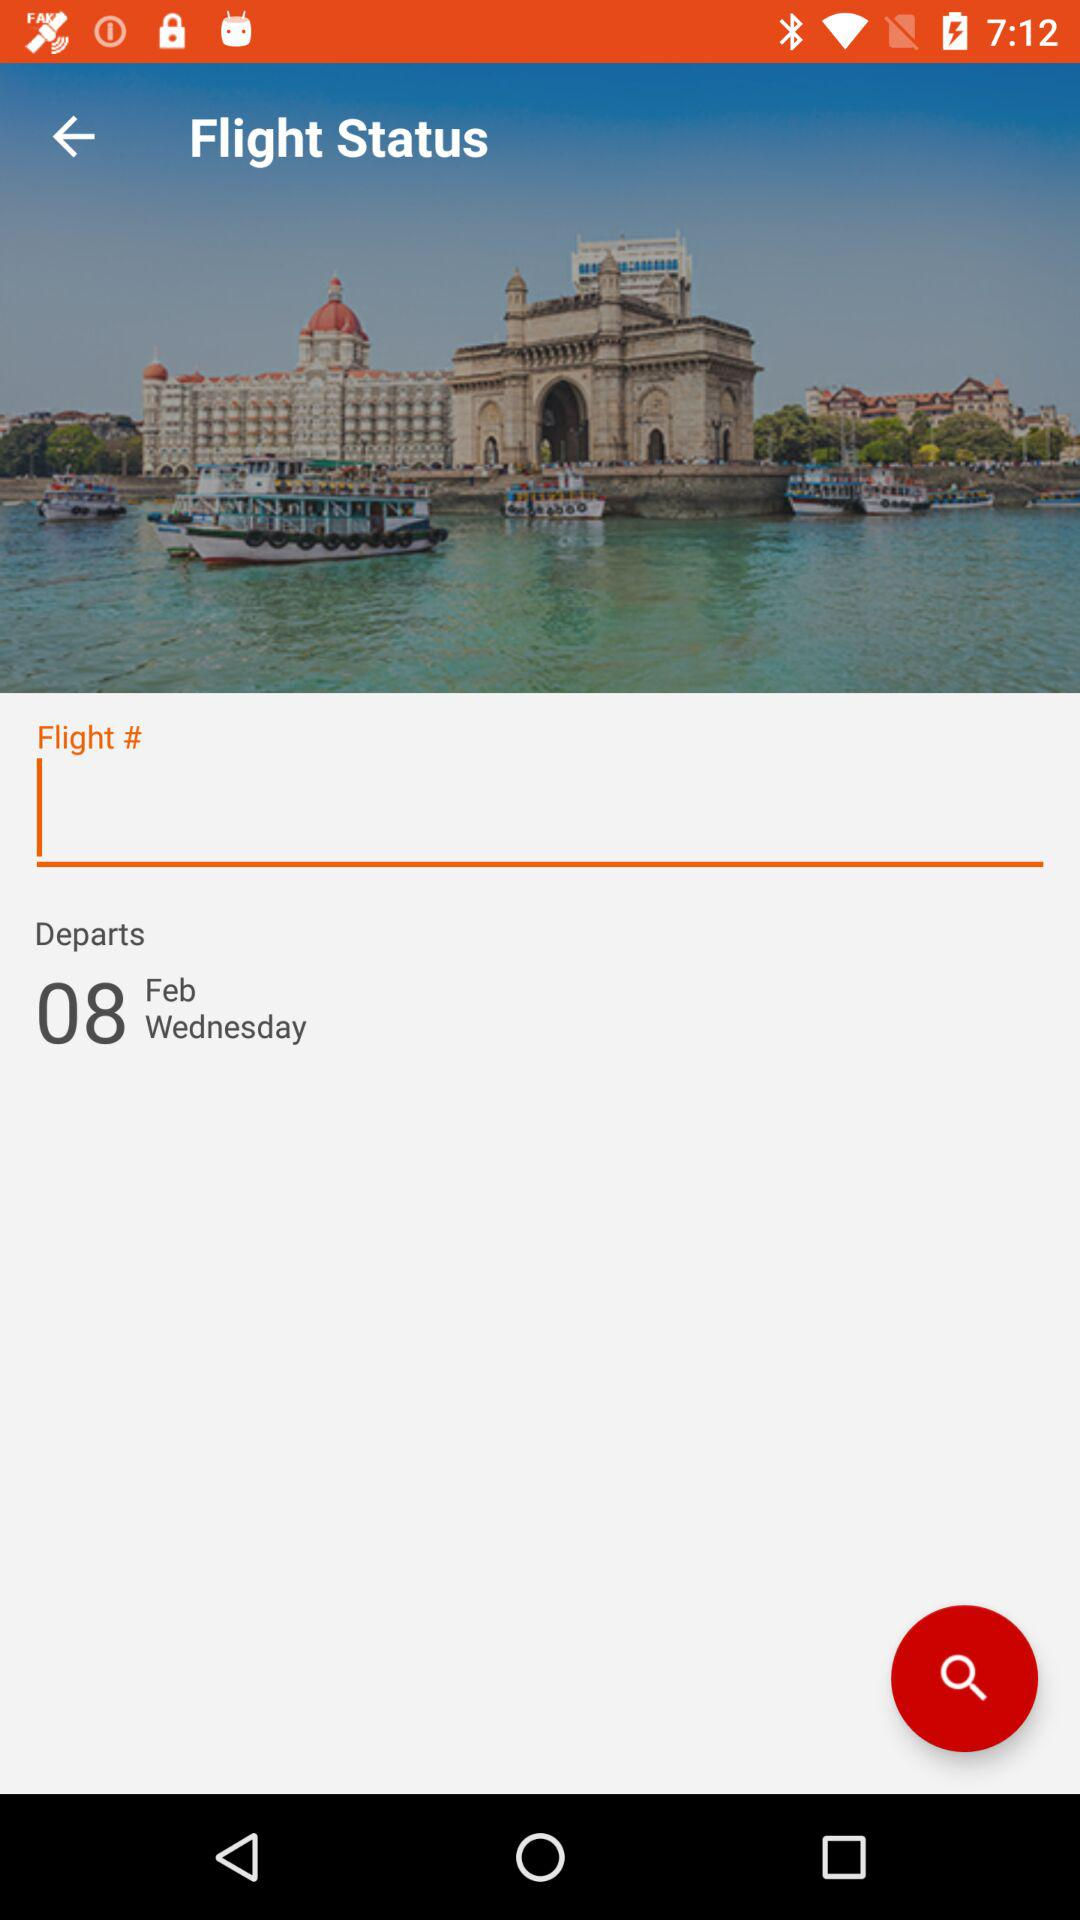When is the flight scheduled to depart? The flight is scheduled to depart on Wednesday, February 8. 